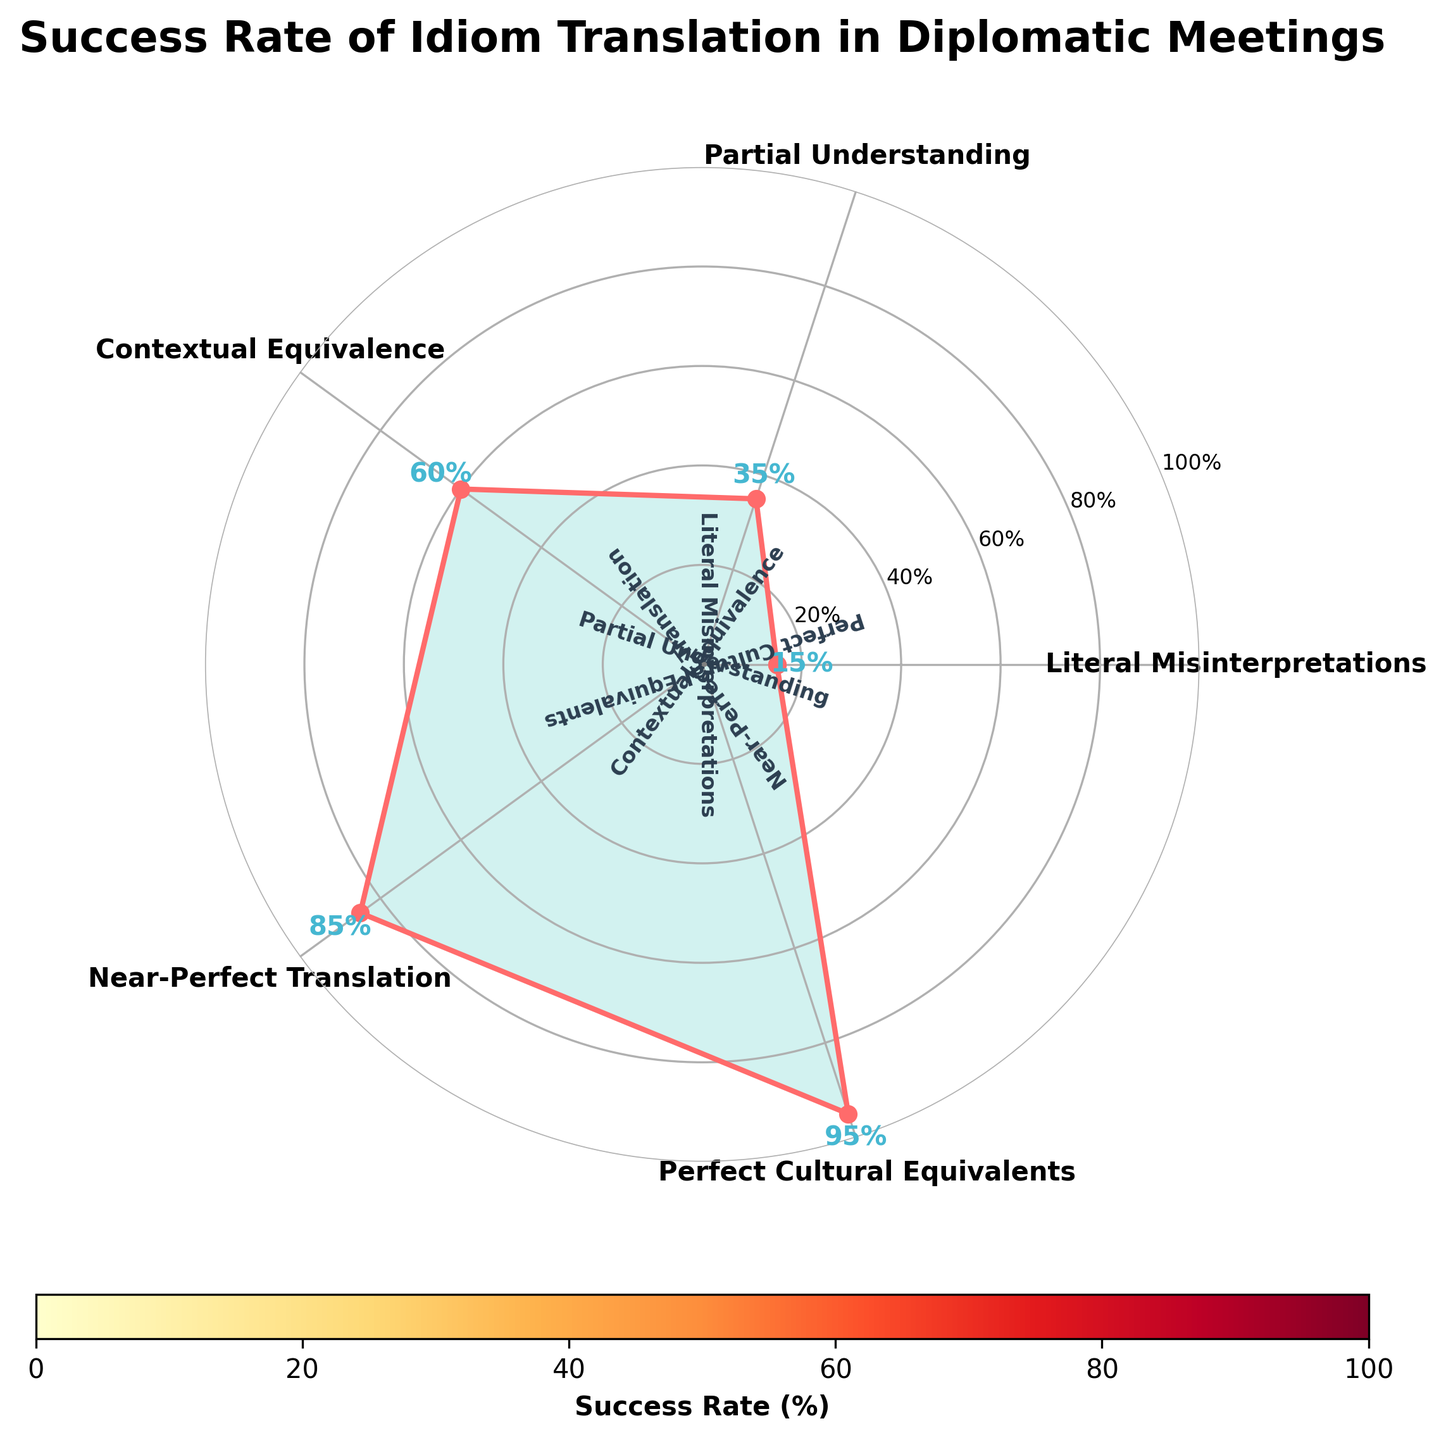How many categories are presented in the gauge chart? By counting the number of labels, we see there are 5 different categories in the chart.
Answer: 5 What is the success rate for the "Near-Perfect Translation" category? The gauge chart shows the "Near-Perfect Translation" category with a corresponding value of 85% next to the label.
Answer: 85% Which category has the highest success rate? By examining the figure, the category "Perfect Cultural Equivalents" has the highest success rate at 95%.
Answer: Perfect Cultural Equivalents What is the difference in success rate between "Partial Understanding" and "Contextual Equivalence"? "Partial Understanding" has a success rate of 35%, and "Contextual Equivalence" is at 60%. The difference is calculated as 60% - 35% = 25%.
Answer: 25% Which success rate value is displayed closest to the top of the gauge chart? The top of the gauge chart aligns with the maximum value, which in this case is the "Perfect Cultural Equivalents" category at 95%.
Answer: Perfect Cultural Equivalents Is there any category with a success rate below 20%? The category "Literal Misinterpretations" has a success rate of 15%, which is below 20%.
Answer: Yes What is the average success rate of all categories presented? Sum the success rates (15 + 35 + 60 + 85 + 95) = 290, then divide by the number of categories (5). The average success rate is 290 / 5 = 58%.
Answer: 58% How does the success rate of "Contextual Equivalence" compare to the midway point (50%) on the gauge chart? The "Contextual Equivalence" category has a 60% success rate, which is 10% higher than the midway point of 50%.
Answer: Higher by 10% What cultural idiom translation category is represented in the green shading of the gauge chart? The chart shading is not verbalized directly, but by observing the color bands, Near-Perfect Translation and Perfect Cultural Equivalents) is likely represented in the green shading as successful translation typically uses green as an indicator of high performance.
Answer: Near-Perfect Translation and Perfect Cultural Equivalents 